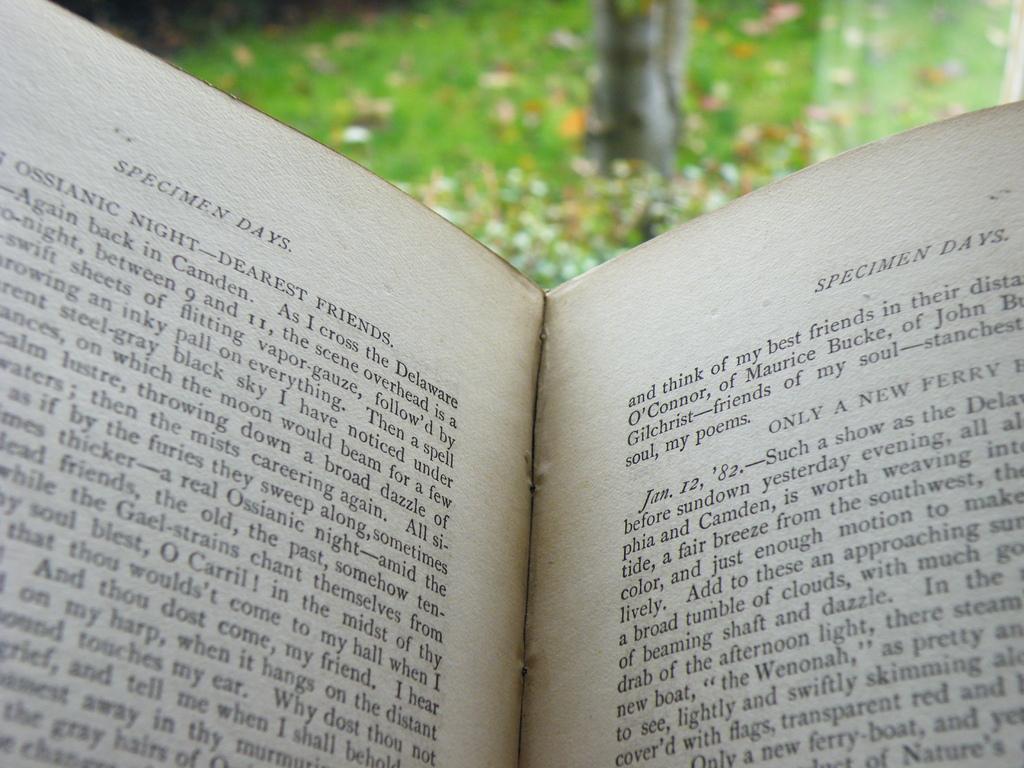What is the name of this book or chapter?
Offer a very short reply. Specimen days. What date is displayed in the beginning of a paragraph?
Your response must be concise. Jan. 12, '82. 